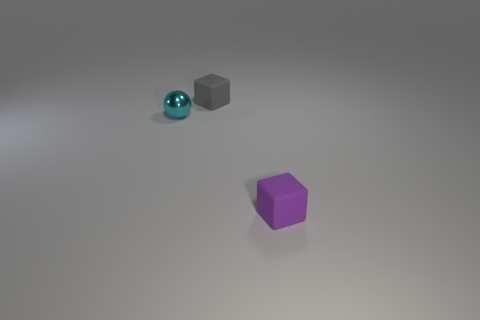Add 2 small metallic spheres. How many objects exist? 5 Subtract all blocks. How many objects are left? 1 Subtract 0 brown cylinders. How many objects are left? 3 Subtract all big blue metallic balls. Subtract all tiny purple blocks. How many objects are left? 2 Add 3 rubber objects. How many rubber objects are left? 5 Add 3 purple rubber cylinders. How many purple rubber cylinders exist? 3 